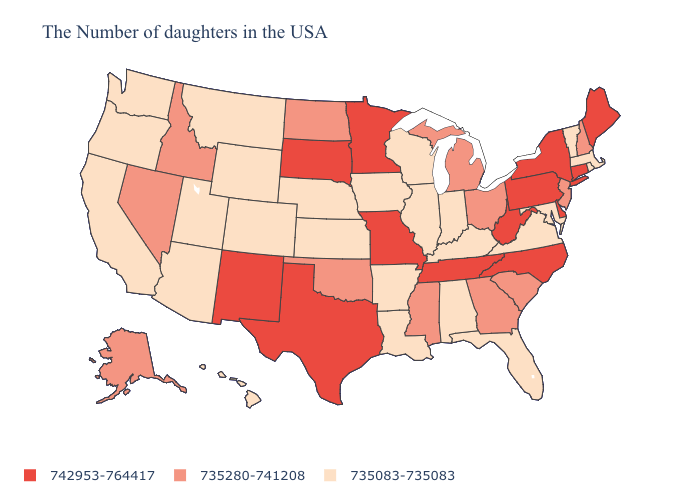Among the states that border Utah , does Nevada have the highest value?
Give a very brief answer. No. What is the lowest value in the USA?
Keep it brief. 735083-735083. Name the states that have a value in the range 735280-741208?
Answer briefly. New Hampshire, New Jersey, South Carolina, Ohio, Georgia, Michigan, Mississippi, Oklahoma, North Dakota, Idaho, Nevada, Alaska. Among the states that border Delaware , which have the lowest value?
Keep it brief. Maryland. Among the states that border Wisconsin , which have the lowest value?
Keep it brief. Illinois, Iowa. Does Kentucky have a higher value than Louisiana?
Be succinct. No. Among the states that border Arizona , which have the highest value?
Short answer required. New Mexico. What is the lowest value in states that border Connecticut?
Be succinct. 735083-735083. Which states have the highest value in the USA?
Concise answer only. Maine, Connecticut, New York, Delaware, Pennsylvania, North Carolina, West Virginia, Tennessee, Missouri, Minnesota, Texas, South Dakota, New Mexico. What is the highest value in the USA?
Answer briefly. 742953-764417. Name the states that have a value in the range 742953-764417?
Concise answer only. Maine, Connecticut, New York, Delaware, Pennsylvania, North Carolina, West Virginia, Tennessee, Missouri, Minnesota, Texas, South Dakota, New Mexico. What is the value of Minnesota?
Answer briefly. 742953-764417. What is the value of Vermont?
Write a very short answer. 735083-735083. Does Maine have the highest value in the USA?
Be succinct. Yes. Name the states that have a value in the range 735280-741208?
Short answer required. New Hampshire, New Jersey, South Carolina, Ohio, Georgia, Michigan, Mississippi, Oklahoma, North Dakota, Idaho, Nevada, Alaska. 